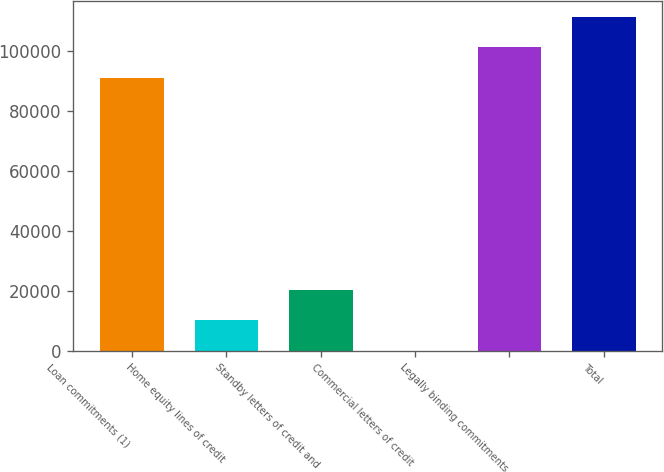<chart> <loc_0><loc_0><loc_500><loc_500><bar_chart><fcel>Loan commitments (1)<fcel>Home equity lines of credit<fcel>Standby letters of credit and<fcel>Commercial letters of credit<fcel>Legally binding commitments<fcel>Total<nl><fcel>90988<fcel>10074.4<fcel>20121.8<fcel>27<fcel>101035<fcel>111083<nl></chart> 